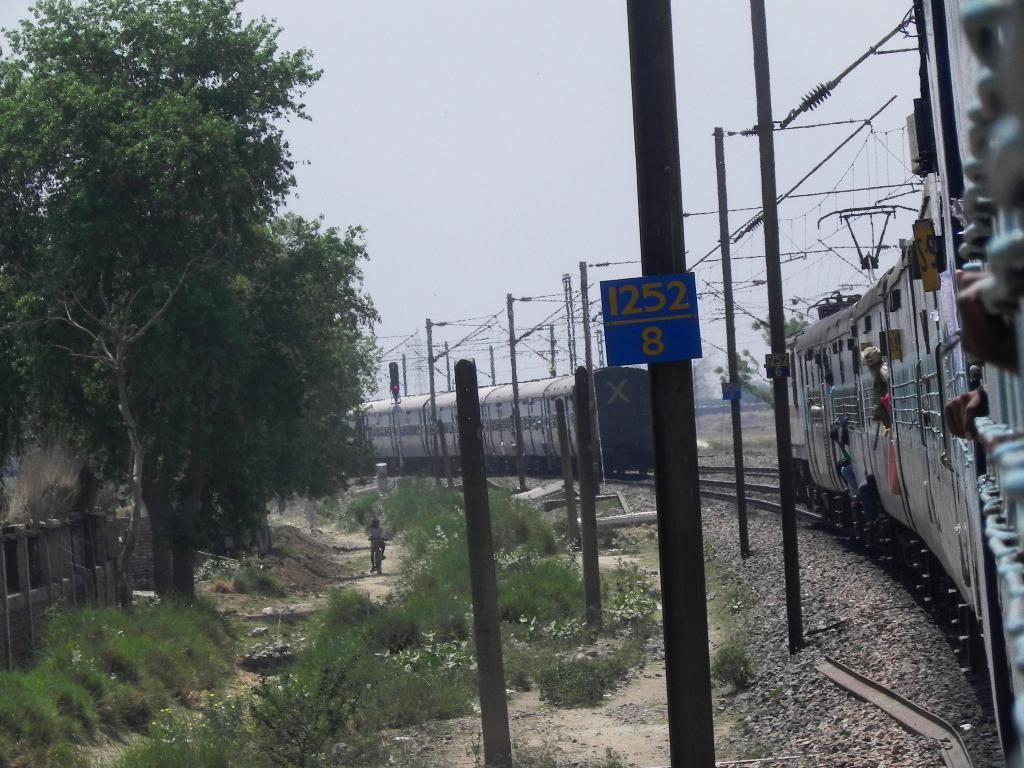What type of vehicles can be seen on the railway track in the image? There are trains on the railway track in the image. What else can be seen in the image besides the trains? Electric cables, poles, shrubs, a person riding a bicycle, trees, a wooden fence, and the sky are visible in the image. Can you describe the person riding a bicycle in the image? The person is riding a bicycle in the image. What type of vegetation is present in the image? Shrubs and trees are present in the image. What is the purpose of the wooden fence in the image? The wooden fence serves as a barrier or boundary in the image. How many scarecrows are standing in the fields in the image? There are no scarecrows present in the image. What is the wealth of the person riding a bicycle in the image? The image does not provide any information about the person's wealth. 